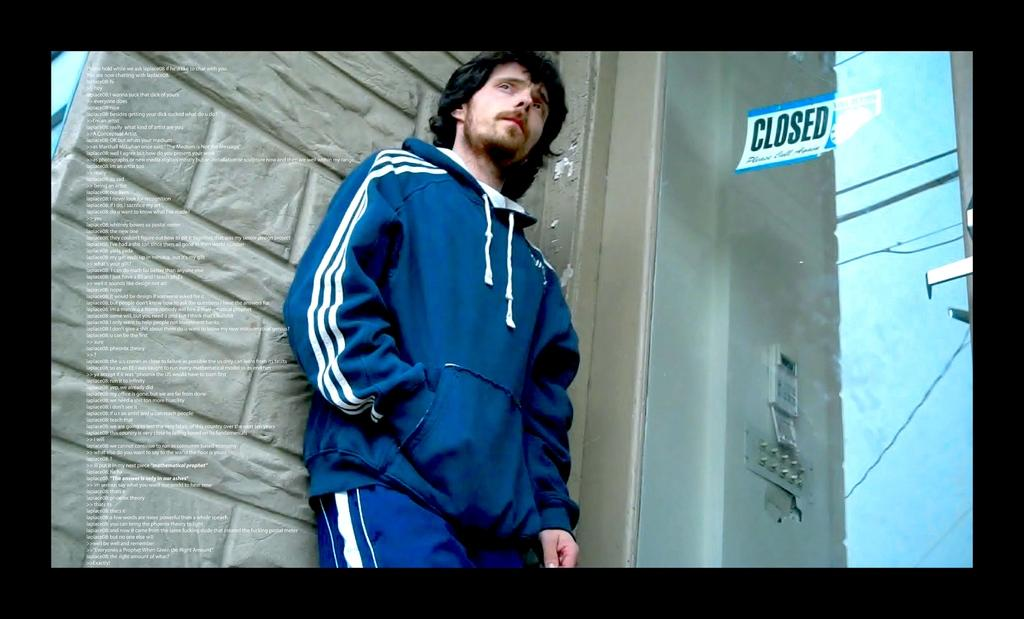<image>
Relay a brief, clear account of the picture shown. A man leans against a wall with a closed sign hanging to his left.. 